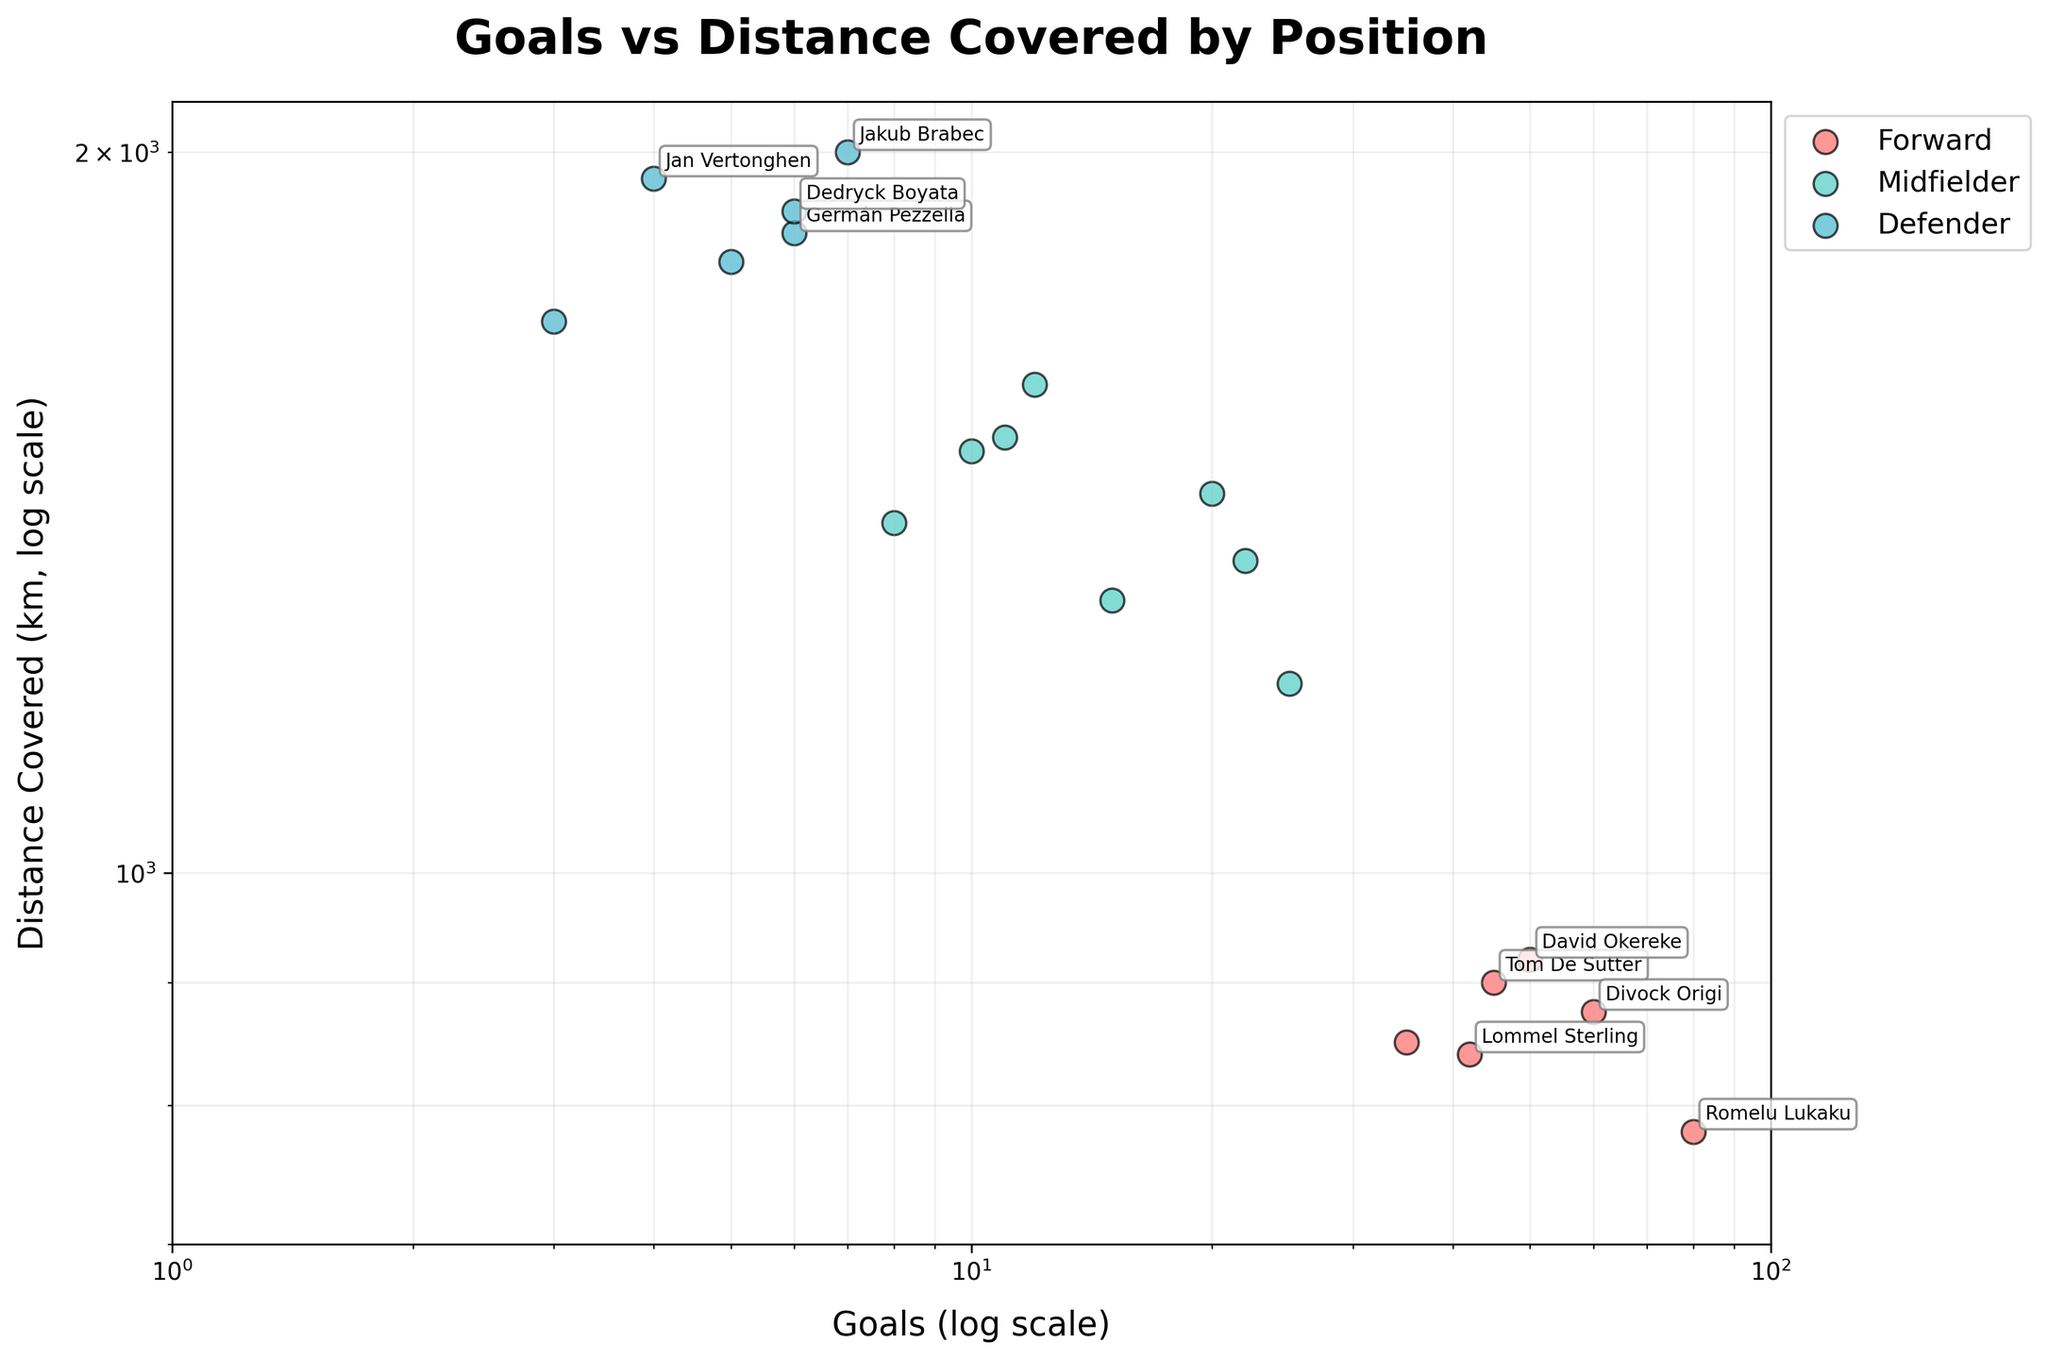How many players are categorized as Forwards in the plot? You can tell the number of Forwards by counting the red points on the scatter plot labeled with the category 'Forward.'
Answer: 6 Which category of player covers the most distance? To find the category of player that covers the most distance, look for the furthest point to the right within each color category on the log-scale y-axis representing "Distance Covered (km)". The defenders, represented in blue, have the highest distance with a point reaching 2000 km.
Answer: Defenders Who is the player with the most goals, and which position does he play? Identify the highest point on the log-scale x-axis representing "Goals" and check the label near that point. The highest goal scorer is Romelu Lukaku playing as a Forward.
Answer: Romelu Lukaku, Forward What's the average distance covered by Midfielders? Locate all the blue points representing Midfielders on the plot, sum their y-coordinate values ("Distance Covered (km)"), and divide by the number of midfielders.
Answer: 1463 km Which player has more than 40 goals and covers a distance of more than 900 km? Identify points that satisfy both conditions by finding points above 40 on the x-axis and to the right of 900 on the y-axis. David Okereke is the only player who meets both criteria.
Answer: David Okereke Compare the number of assists between the player who has covered the most distance and the player with the most goals. Who has more assists? Find the player who covered the most distance, Jakub Brabec, as represented within blue circles; and compare his assists with Romelu Lukaku, the player with the most goals. Jakub Brabec has 10 assists, while Romelu Lukaku has 40 assists.
Answer: Romelu Lukaku has more assists Are there any players that have less than 20 goals but have covered a distance of over 1800 km? Identify any points on the plot that are below 20 on the log-scale x-axis and above 1800 on the log-scale y-axis. Jan Vertonghen and Dedryck Boyata are the players who meet these criteria.
Answer: Jan Vertonghen and Dedryck Boyata What is the range of distances covered by players in the Forward position? To find the range of distances covered, note the lowest and highest points among the red points on the y-axis. The range is from 780 km to 920 km.
Answer: 780 km to 920 km 